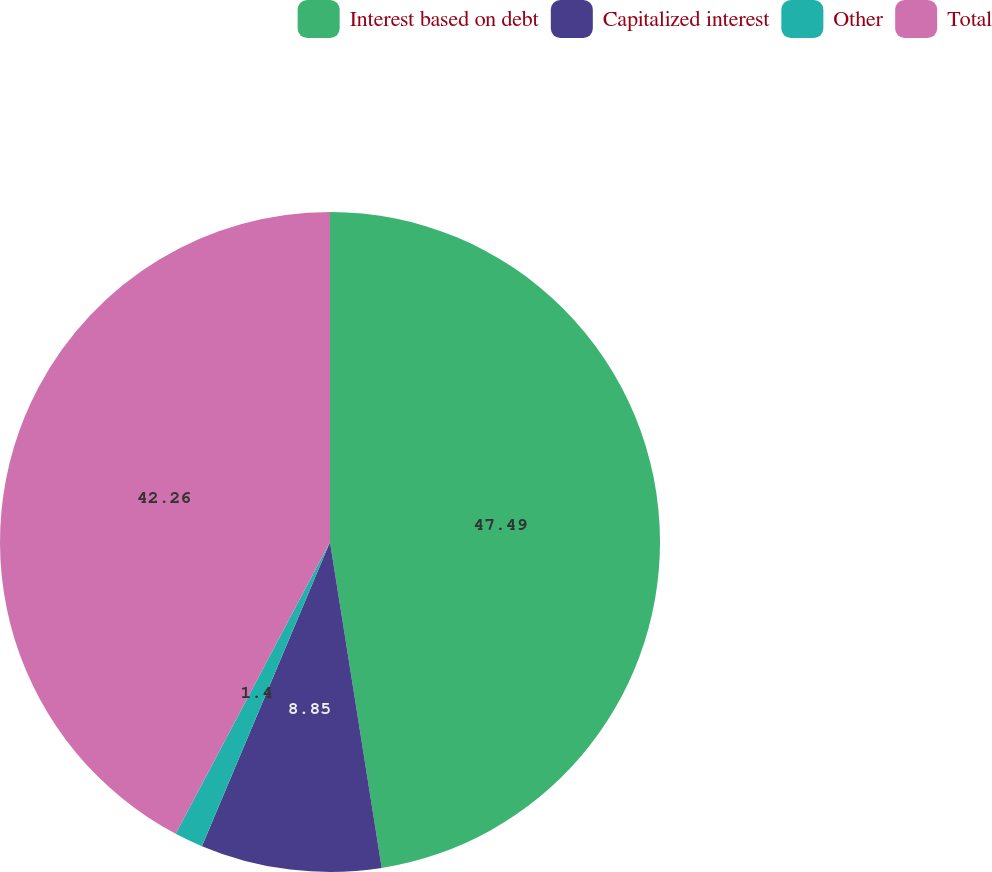Convert chart to OTSL. <chart><loc_0><loc_0><loc_500><loc_500><pie_chart><fcel>Interest based on debt<fcel>Capitalized interest<fcel>Other<fcel>Total<nl><fcel>47.5%<fcel>8.85%<fcel>1.4%<fcel>42.26%<nl></chart> 